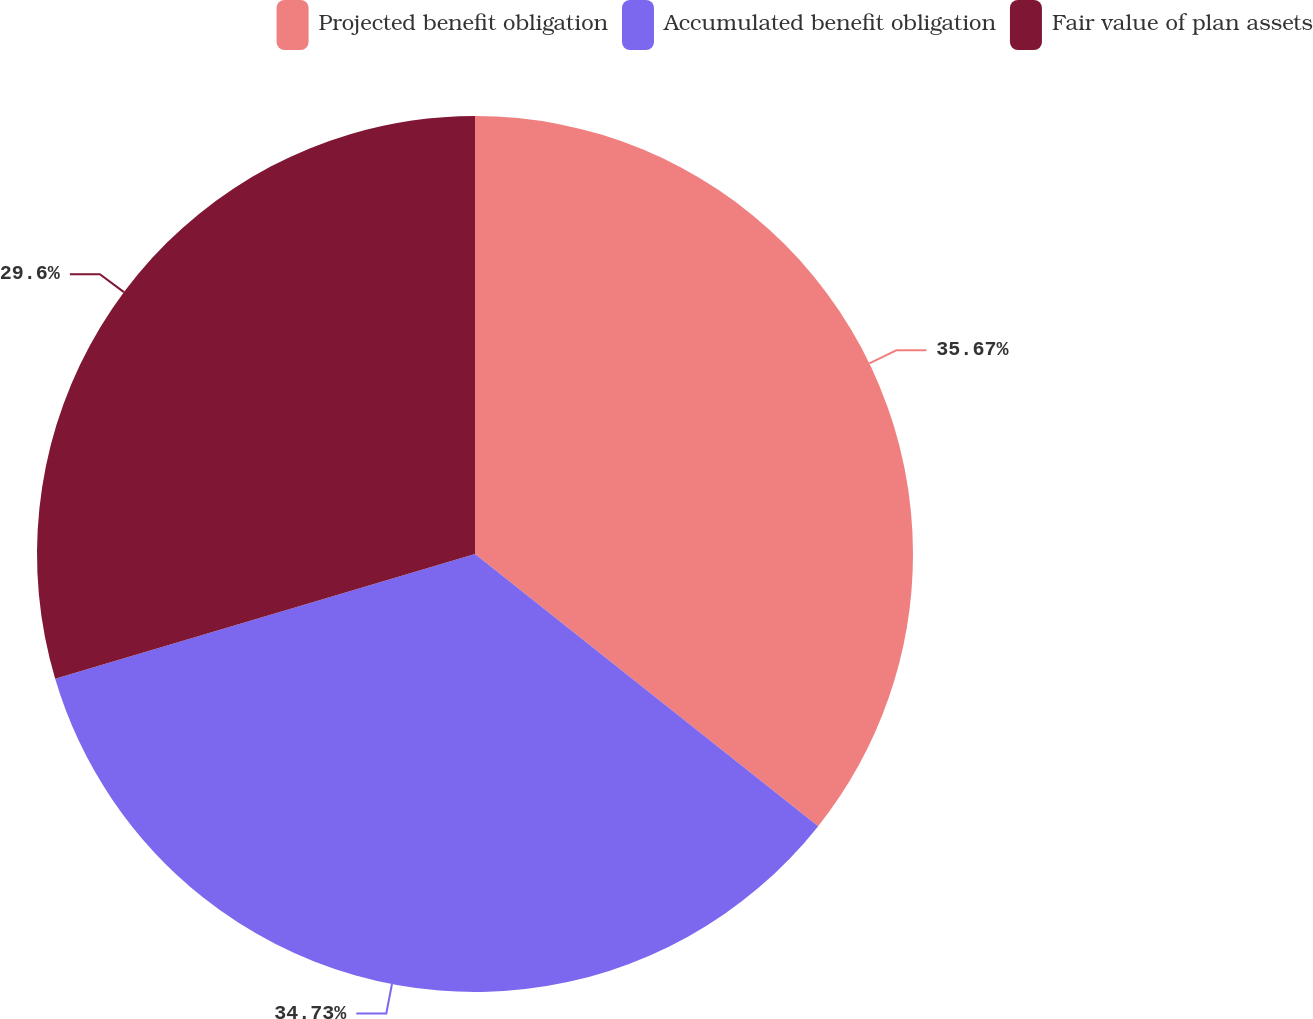Convert chart. <chart><loc_0><loc_0><loc_500><loc_500><pie_chart><fcel>Projected benefit obligation<fcel>Accumulated benefit obligation<fcel>Fair value of plan assets<nl><fcel>35.67%<fcel>34.73%<fcel>29.6%<nl></chart> 